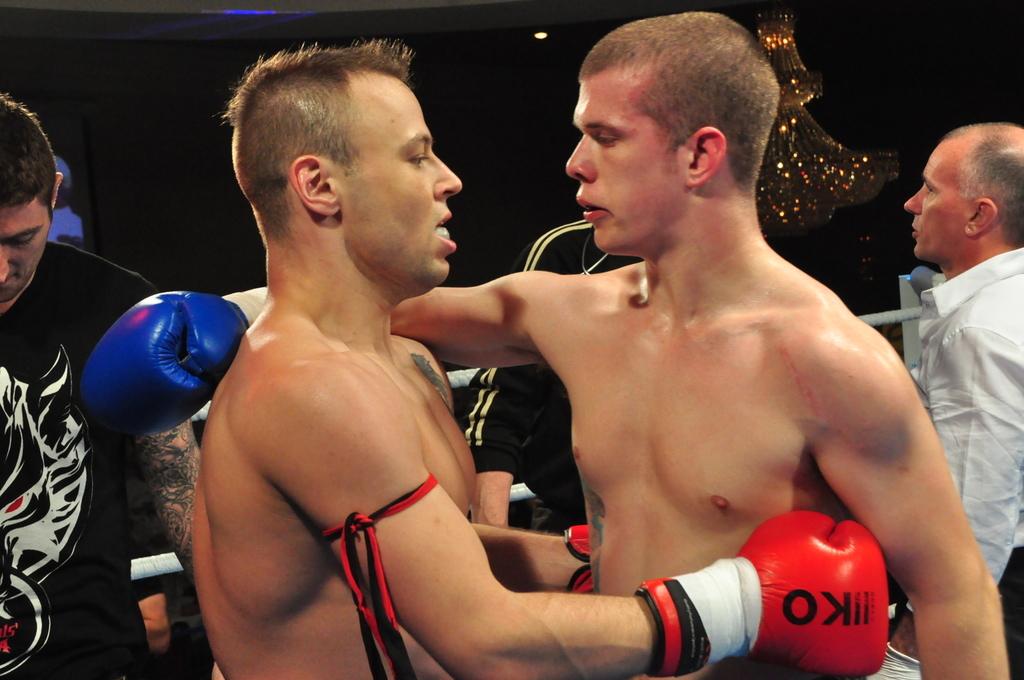What is written on the boxer's gloves?
Your answer should be very brief. Ko. 